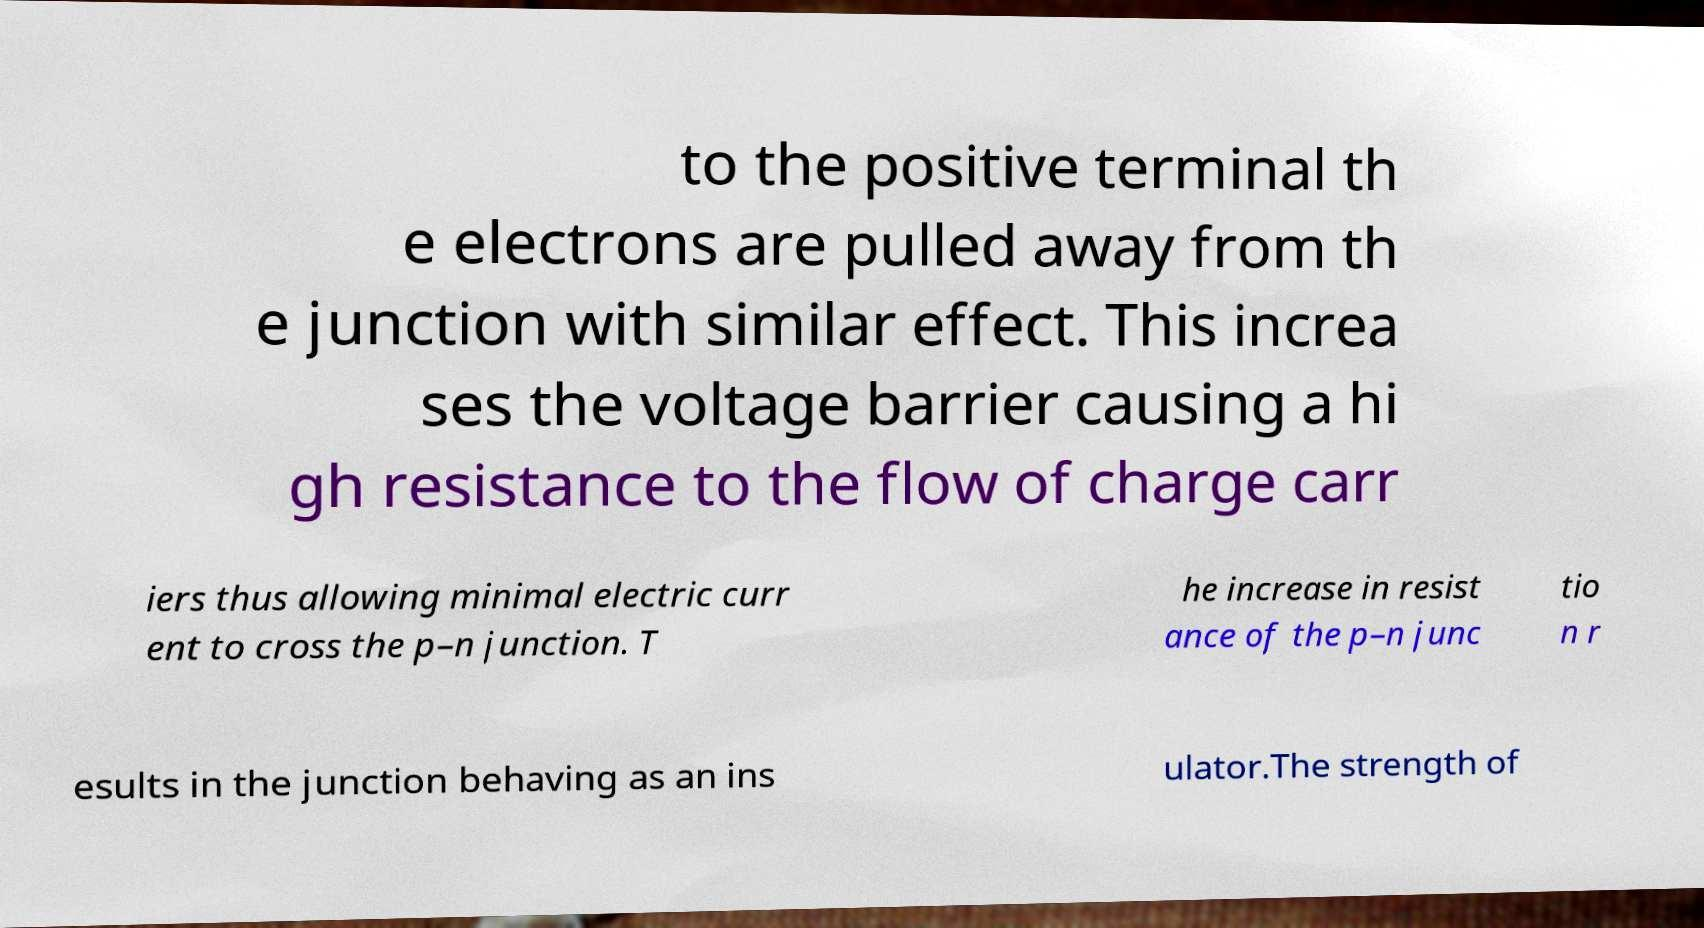What messages or text are displayed in this image? I need them in a readable, typed format. to the positive terminal th e electrons are pulled away from th e junction with similar effect. This increa ses the voltage barrier causing a hi gh resistance to the flow of charge carr iers thus allowing minimal electric curr ent to cross the p–n junction. T he increase in resist ance of the p–n junc tio n r esults in the junction behaving as an ins ulator.The strength of 